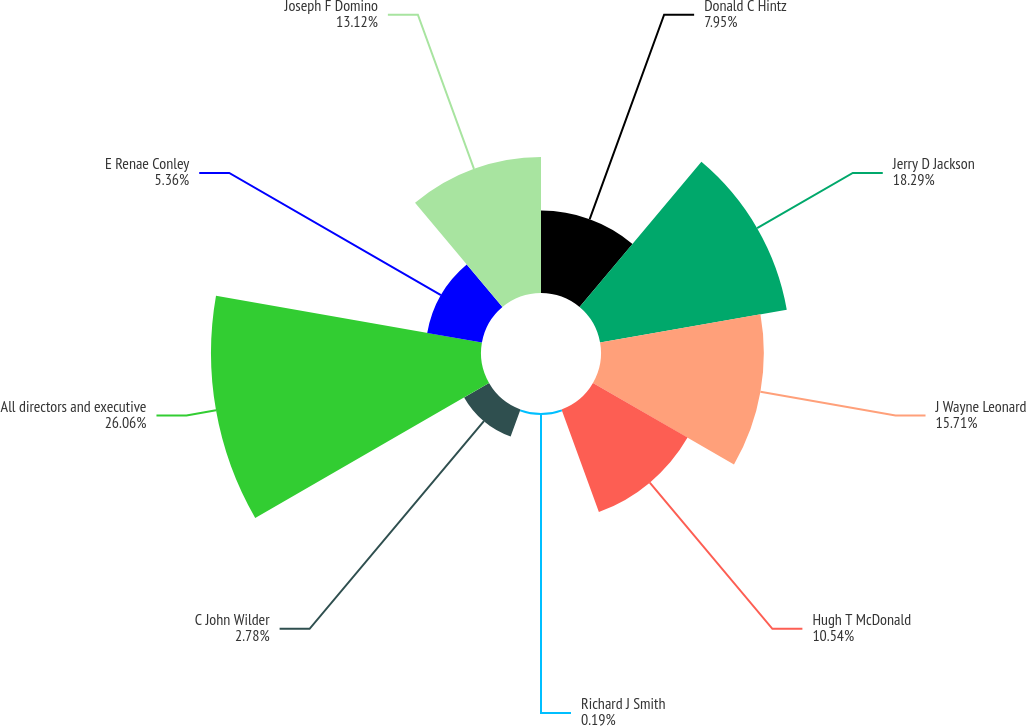Convert chart. <chart><loc_0><loc_0><loc_500><loc_500><pie_chart><fcel>Donald C Hintz<fcel>Jerry D Jackson<fcel>J Wayne Leonard<fcel>Hugh T McDonald<fcel>Richard J Smith<fcel>C John Wilder<fcel>All directors and executive<fcel>E Renae Conley<fcel>Joseph F Domino<nl><fcel>7.95%<fcel>18.29%<fcel>15.71%<fcel>10.54%<fcel>0.19%<fcel>2.78%<fcel>26.05%<fcel>5.36%<fcel>13.12%<nl></chart> 